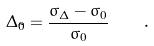Convert formula to latex. <formula><loc_0><loc_0><loc_500><loc_500>\Delta _ { \tilde { 0 } } = \frac { \sigma _ { \Delta } - \sigma _ { 0 } } { \sigma _ { 0 } } \quad .</formula> 